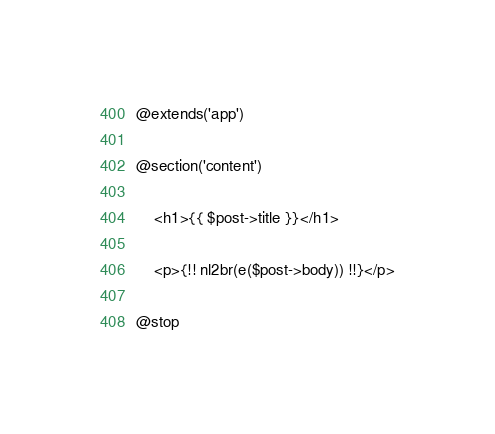<code> <loc_0><loc_0><loc_500><loc_500><_PHP_>@extends('app')

@section('content')

    <h1>{{ $post->title }}</h1>

    <p>{!! nl2br(e($post->body)) !!}</p>

@stop</code> 